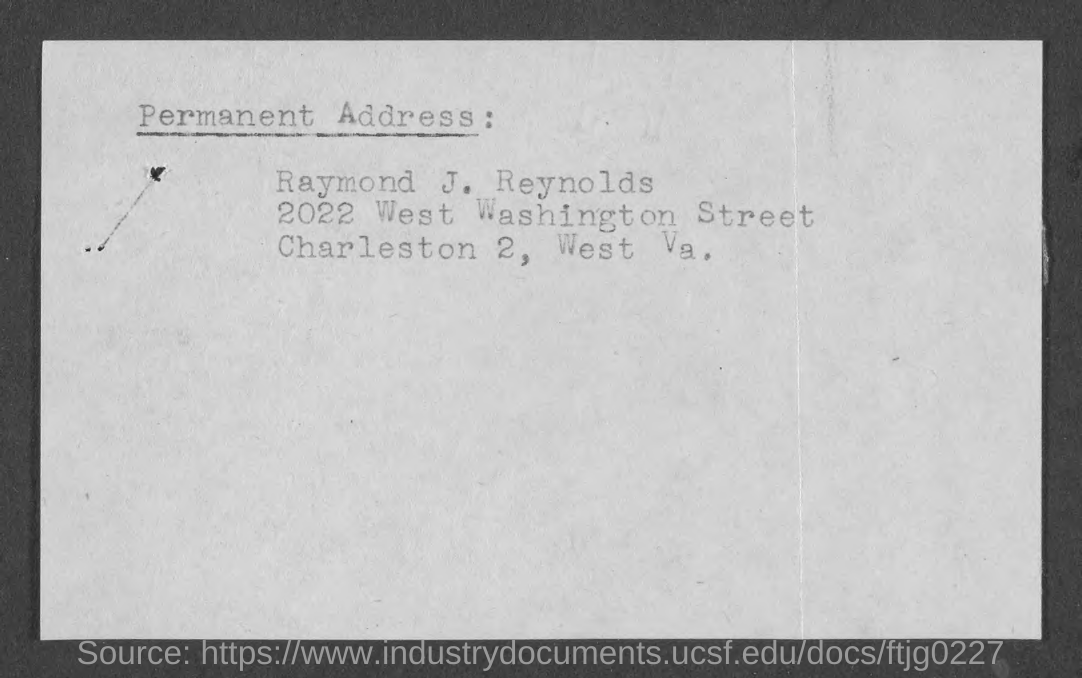What is the name of the person given in the permanent address?
Your answer should be very brief. Raymond J. Reynolds. 